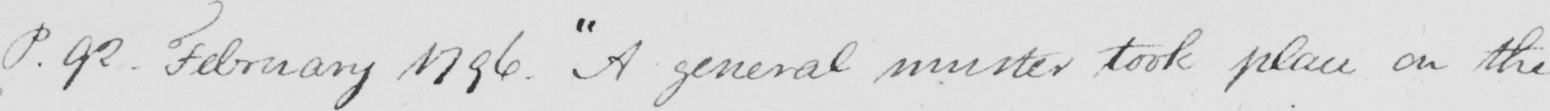Please transcribe the handwritten text in this image. P . 92 . February 1796 .  " A general muster took place on the 